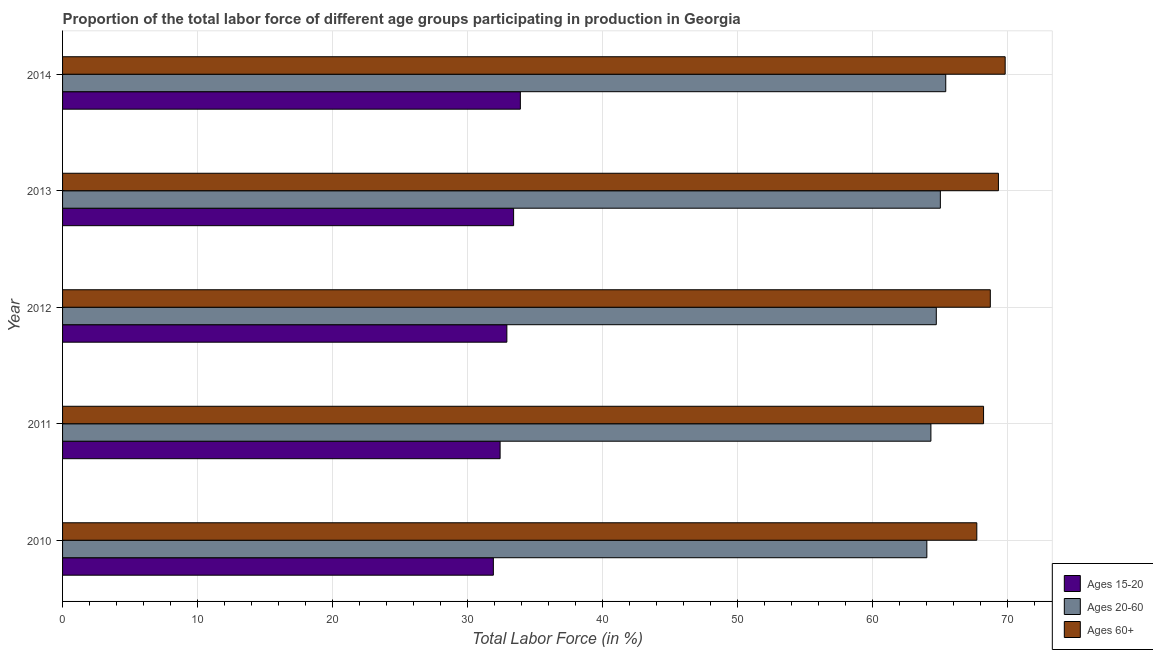In how many cases, is the number of bars for a given year not equal to the number of legend labels?
Your answer should be compact. 0. What is the percentage of labor force above age 60 in 2010?
Keep it short and to the point. 67.7. Across all years, what is the maximum percentage of labor force within the age group 20-60?
Your response must be concise. 65.4. Across all years, what is the minimum percentage of labor force above age 60?
Provide a succinct answer. 67.7. In which year was the percentage of labor force within the age group 20-60 minimum?
Provide a short and direct response. 2010. What is the total percentage of labor force above age 60 in the graph?
Your answer should be very brief. 343.7. What is the difference between the percentage of labor force within the age group 15-20 in 2013 and that in 2014?
Make the answer very short. -0.5. What is the difference between the percentage of labor force above age 60 in 2013 and the percentage of labor force within the age group 15-20 in 2011?
Ensure brevity in your answer.  36.9. What is the average percentage of labor force within the age group 20-60 per year?
Give a very brief answer. 64.68. In the year 2010, what is the difference between the percentage of labor force within the age group 20-60 and percentage of labor force above age 60?
Give a very brief answer. -3.7. What is the ratio of the percentage of labor force within the age group 15-20 in 2010 to that in 2014?
Your answer should be compact. 0.94. Is the difference between the percentage of labor force within the age group 15-20 in 2010 and 2014 greater than the difference between the percentage of labor force above age 60 in 2010 and 2014?
Give a very brief answer. Yes. What is the difference between the highest and the lowest percentage of labor force above age 60?
Your answer should be compact. 2.1. What does the 3rd bar from the top in 2012 represents?
Ensure brevity in your answer.  Ages 15-20. What does the 2nd bar from the bottom in 2014 represents?
Provide a short and direct response. Ages 20-60. Is it the case that in every year, the sum of the percentage of labor force within the age group 15-20 and percentage of labor force within the age group 20-60 is greater than the percentage of labor force above age 60?
Your answer should be very brief. Yes. How many bars are there?
Provide a succinct answer. 15. How many years are there in the graph?
Provide a succinct answer. 5. Are the values on the major ticks of X-axis written in scientific E-notation?
Ensure brevity in your answer.  No. Does the graph contain grids?
Give a very brief answer. Yes. How many legend labels are there?
Your answer should be very brief. 3. How are the legend labels stacked?
Offer a terse response. Vertical. What is the title of the graph?
Offer a terse response. Proportion of the total labor force of different age groups participating in production in Georgia. Does "Industrial Nitrous Oxide" appear as one of the legend labels in the graph?
Provide a succinct answer. No. What is the label or title of the X-axis?
Ensure brevity in your answer.  Total Labor Force (in %). What is the label or title of the Y-axis?
Keep it short and to the point. Year. What is the Total Labor Force (in %) of Ages 15-20 in 2010?
Make the answer very short. 31.9. What is the Total Labor Force (in %) in Ages 60+ in 2010?
Provide a short and direct response. 67.7. What is the Total Labor Force (in %) in Ages 15-20 in 2011?
Make the answer very short. 32.4. What is the Total Labor Force (in %) in Ages 20-60 in 2011?
Keep it short and to the point. 64.3. What is the Total Labor Force (in %) of Ages 60+ in 2011?
Make the answer very short. 68.2. What is the Total Labor Force (in %) in Ages 15-20 in 2012?
Keep it short and to the point. 32.9. What is the Total Labor Force (in %) of Ages 20-60 in 2012?
Your response must be concise. 64.7. What is the Total Labor Force (in %) of Ages 60+ in 2012?
Your answer should be compact. 68.7. What is the Total Labor Force (in %) of Ages 15-20 in 2013?
Your answer should be compact. 33.4. What is the Total Labor Force (in %) of Ages 20-60 in 2013?
Your answer should be compact. 65. What is the Total Labor Force (in %) in Ages 60+ in 2013?
Make the answer very short. 69.3. What is the Total Labor Force (in %) of Ages 15-20 in 2014?
Offer a very short reply. 33.9. What is the Total Labor Force (in %) of Ages 20-60 in 2014?
Make the answer very short. 65.4. What is the Total Labor Force (in %) of Ages 60+ in 2014?
Provide a short and direct response. 69.8. Across all years, what is the maximum Total Labor Force (in %) of Ages 15-20?
Offer a terse response. 33.9. Across all years, what is the maximum Total Labor Force (in %) of Ages 20-60?
Give a very brief answer. 65.4. Across all years, what is the maximum Total Labor Force (in %) of Ages 60+?
Ensure brevity in your answer.  69.8. Across all years, what is the minimum Total Labor Force (in %) in Ages 15-20?
Your answer should be very brief. 31.9. Across all years, what is the minimum Total Labor Force (in %) of Ages 60+?
Offer a terse response. 67.7. What is the total Total Labor Force (in %) in Ages 15-20 in the graph?
Offer a very short reply. 164.5. What is the total Total Labor Force (in %) of Ages 20-60 in the graph?
Provide a short and direct response. 323.4. What is the total Total Labor Force (in %) in Ages 60+ in the graph?
Your answer should be compact. 343.7. What is the difference between the Total Labor Force (in %) of Ages 15-20 in 2010 and that in 2011?
Your answer should be compact. -0.5. What is the difference between the Total Labor Force (in %) of Ages 60+ in 2010 and that in 2011?
Offer a very short reply. -0.5. What is the difference between the Total Labor Force (in %) of Ages 15-20 in 2010 and that in 2012?
Make the answer very short. -1. What is the difference between the Total Labor Force (in %) of Ages 60+ in 2010 and that in 2013?
Your answer should be very brief. -1.6. What is the difference between the Total Labor Force (in %) of Ages 20-60 in 2010 and that in 2014?
Your answer should be very brief. -1.4. What is the difference between the Total Labor Force (in %) in Ages 60+ in 2010 and that in 2014?
Your response must be concise. -2.1. What is the difference between the Total Labor Force (in %) of Ages 60+ in 2011 and that in 2013?
Keep it short and to the point. -1.1. What is the difference between the Total Labor Force (in %) in Ages 15-20 in 2011 and that in 2014?
Make the answer very short. -1.5. What is the difference between the Total Labor Force (in %) of Ages 20-60 in 2011 and that in 2014?
Your answer should be very brief. -1.1. What is the difference between the Total Labor Force (in %) of Ages 60+ in 2011 and that in 2014?
Give a very brief answer. -1.6. What is the difference between the Total Labor Force (in %) in Ages 15-20 in 2012 and that in 2013?
Offer a very short reply. -0.5. What is the difference between the Total Labor Force (in %) in Ages 20-60 in 2012 and that in 2013?
Your answer should be very brief. -0.3. What is the difference between the Total Labor Force (in %) of Ages 60+ in 2012 and that in 2013?
Make the answer very short. -0.6. What is the difference between the Total Labor Force (in %) of Ages 20-60 in 2012 and that in 2014?
Provide a short and direct response. -0.7. What is the difference between the Total Labor Force (in %) in Ages 20-60 in 2013 and that in 2014?
Provide a succinct answer. -0.4. What is the difference between the Total Labor Force (in %) in Ages 15-20 in 2010 and the Total Labor Force (in %) in Ages 20-60 in 2011?
Your answer should be very brief. -32.4. What is the difference between the Total Labor Force (in %) of Ages 15-20 in 2010 and the Total Labor Force (in %) of Ages 60+ in 2011?
Your answer should be compact. -36.3. What is the difference between the Total Labor Force (in %) of Ages 20-60 in 2010 and the Total Labor Force (in %) of Ages 60+ in 2011?
Your answer should be very brief. -4.2. What is the difference between the Total Labor Force (in %) of Ages 15-20 in 2010 and the Total Labor Force (in %) of Ages 20-60 in 2012?
Your answer should be compact. -32.8. What is the difference between the Total Labor Force (in %) in Ages 15-20 in 2010 and the Total Labor Force (in %) in Ages 60+ in 2012?
Offer a terse response. -36.8. What is the difference between the Total Labor Force (in %) in Ages 15-20 in 2010 and the Total Labor Force (in %) in Ages 20-60 in 2013?
Your response must be concise. -33.1. What is the difference between the Total Labor Force (in %) in Ages 15-20 in 2010 and the Total Labor Force (in %) in Ages 60+ in 2013?
Ensure brevity in your answer.  -37.4. What is the difference between the Total Labor Force (in %) in Ages 20-60 in 2010 and the Total Labor Force (in %) in Ages 60+ in 2013?
Provide a short and direct response. -5.3. What is the difference between the Total Labor Force (in %) of Ages 15-20 in 2010 and the Total Labor Force (in %) of Ages 20-60 in 2014?
Give a very brief answer. -33.5. What is the difference between the Total Labor Force (in %) in Ages 15-20 in 2010 and the Total Labor Force (in %) in Ages 60+ in 2014?
Your answer should be very brief. -37.9. What is the difference between the Total Labor Force (in %) of Ages 15-20 in 2011 and the Total Labor Force (in %) of Ages 20-60 in 2012?
Provide a succinct answer. -32.3. What is the difference between the Total Labor Force (in %) in Ages 15-20 in 2011 and the Total Labor Force (in %) in Ages 60+ in 2012?
Your response must be concise. -36.3. What is the difference between the Total Labor Force (in %) in Ages 15-20 in 2011 and the Total Labor Force (in %) in Ages 20-60 in 2013?
Your answer should be very brief. -32.6. What is the difference between the Total Labor Force (in %) in Ages 15-20 in 2011 and the Total Labor Force (in %) in Ages 60+ in 2013?
Your answer should be very brief. -36.9. What is the difference between the Total Labor Force (in %) of Ages 15-20 in 2011 and the Total Labor Force (in %) of Ages 20-60 in 2014?
Your response must be concise. -33. What is the difference between the Total Labor Force (in %) in Ages 15-20 in 2011 and the Total Labor Force (in %) in Ages 60+ in 2014?
Keep it short and to the point. -37.4. What is the difference between the Total Labor Force (in %) in Ages 15-20 in 2012 and the Total Labor Force (in %) in Ages 20-60 in 2013?
Provide a succinct answer. -32.1. What is the difference between the Total Labor Force (in %) in Ages 15-20 in 2012 and the Total Labor Force (in %) in Ages 60+ in 2013?
Keep it short and to the point. -36.4. What is the difference between the Total Labor Force (in %) of Ages 20-60 in 2012 and the Total Labor Force (in %) of Ages 60+ in 2013?
Your answer should be compact. -4.6. What is the difference between the Total Labor Force (in %) in Ages 15-20 in 2012 and the Total Labor Force (in %) in Ages 20-60 in 2014?
Make the answer very short. -32.5. What is the difference between the Total Labor Force (in %) of Ages 15-20 in 2012 and the Total Labor Force (in %) of Ages 60+ in 2014?
Make the answer very short. -36.9. What is the difference between the Total Labor Force (in %) in Ages 15-20 in 2013 and the Total Labor Force (in %) in Ages 20-60 in 2014?
Provide a short and direct response. -32. What is the difference between the Total Labor Force (in %) of Ages 15-20 in 2013 and the Total Labor Force (in %) of Ages 60+ in 2014?
Ensure brevity in your answer.  -36.4. What is the difference between the Total Labor Force (in %) in Ages 20-60 in 2013 and the Total Labor Force (in %) in Ages 60+ in 2014?
Ensure brevity in your answer.  -4.8. What is the average Total Labor Force (in %) in Ages 15-20 per year?
Your answer should be compact. 32.9. What is the average Total Labor Force (in %) in Ages 20-60 per year?
Your answer should be very brief. 64.68. What is the average Total Labor Force (in %) in Ages 60+ per year?
Your answer should be very brief. 68.74. In the year 2010, what is the difference between the Total Labor Force (in %) of Ages 15-20 and Total Labor Force (in %) of Ages 20-60?
Keep it short and to the point. -32.1. In the year 2010, what is the difference between the Total Labor Force (in %) in Ages 15-20 and Total Labor Force (in %) in Ages 60+?
Your answer should be compact. -35.8. In the year 2010, what is the difference between the Total Labor Force (in %) in Ages 20-60 and Total Labor Force (in %) in Ages 60+?
Provide a short and direct response. -3.7. In the year 2011, what is the difference between the Total Labor Force (in %) in Ages 15-20 and Total Labor Force (in %) in Ages 20-60?
Your response must be concise. -31.9. In the year 2011, what is the difference between the Total Labor Force (in %) in Ages 15-20 and Total Labor Force (in %) in Ages 60+?
Give a very brief answer. -35.8. In the year 2011, what is the difference between the Total Labor Force (in %) in Ages 20-60 and Total Labor Force (in %) in Ages 60+?
Offer a terse response. -3.9. In the year 2012, what is the difference between the Total Labor Force (in %) in Ages 15-20 and Total Labor Force (in %) in Ages 20-60?
Make the answer very short. -31.8. In the year 2012, what is the difference between the Total Labor Force (in %) of Ages 15-20 and Total Labor Force (in %) of Ages 60+?
Ensure brevity in your answer.  -35.8. In the year 2013, what is the difference between the Total Labor Force (in %) of Ages 15-20 and Total Labor Force (in %) of Ages 20-60?
Ensure brevity in your answer.  -31.6. In the year 2013, what is the difference between the Total Labor Force (in %) of Ages 15-20 and Total Labor Force (in %) of Ages 60+?
Your response must be concise. -35.9. In the year 2013, what is the difference between the Total Labor Force (in %) in Ages 20-60 and Total Labor Force (in %) in Ages 60+?
Ensure brevity in your answer.  -4.3. In the year 2014, what is the difference between the Total Labor Force (in %) in Ages 15-20 and Total Labor Force (in %) in Ages 20-60?
Give a very brief answer. -31.5. In the year 2014, what is the difference between the Total Labor Force (in %) of Ages 15-20 and Total Labor Force (in %) of Ages 60+?
Your answer should be very brief. -35.9. In the year 2014, what is the difference between the Total Labor Force (in %) in Ages 20-60 and Total Labor Force (in %) in Ages 60+?
Your answer should be very brief. -4.4. What is the ratio of the Total Labor Force (in %) in Ages 15-20 in 2010 to that in 2011?
Give a very brief answer. 0.98. What is the ratio of the Total Labor Force (in %) in Ages 15-20 in 2010 to that in 2012?
Make the answer very short. 0.97. What is the ratio of the Total Labor Force (in %) in Ages 60+ in 2010 to that in 2012?
Provide a succinct answer. 0.99. What is the ratio of the Total Labor Force (in %) in Ages 15-20 in 2010 to that in 2013?
Provide a short and direct response. 0.96. What is the ratio of the Total Labor Force (in %) in Ages 20-60 in 2010 to that in 2013?
Your response must be concise. 0.98. What is the ratio of the Total Labor Force (in %) in Ages 60+ in 2010 to that in 2013?
Make the answer very short. 0.98. What is the ratio of the Total Labor Force (in %) of Ages 15-20 in 2010 to that in 2014?
Provide a succinct answer. 0.94. What is the ratio of the Total Labor Force (in %) in Ages 20-60 in 2010 to that in 2014?
Provide a succinct answer. 0.98. What is the ratio of the Total Labor Force (in %) of Ages 60+ in 2010 to that in 2014?
Ensure brevity in your answer.  0.97. What is the ratio of the Total Labor Force (in %) of Ages 15-20 in 2011 to that in 2012?
Offer a terse response. 0.98. What is the ratio of the Total Labor Force (in %) of Ages 15-20 in 2011 to that in 2013?
Give a very brief answer. 0.97. What is the ratio of the Total Labor Force (in %) of Ages 60+ in 2011 to that in 2013?
Keep it short and to the point. 0.98. What is the ratio of the Total Labor Force (in %) in Ages 15-20 in 2011 to that in 2014?
Your answer should be compact. 0.96. What is the ratio of the Total Labor Force (in %) in Ages 20-60 in 2011 to that in 2014?
Give a very brief answer. 0.98. What is the ratio of the Total Labor Force (in %) of Ages 60+ in 2011 to that in 2014?
Make the answer very short. 0.98. What is the ratio of the Total Labor Force (in %) in Ages 15-20 in 2012 to that in 2013?
Your response must be concise. 0.98. What is the ratio of the Total Labor Force (in %) in Ages 60+ in 2012 to that in 2013?
Make the answer very short. 0.99. What is the ratio of the Total Labor Force (in %) in Ages 15-20 in 2012 to that in 2014?
Provide a succinct answer. 0.97. What is the ratio of the Total Labor Force (in %) in Ages 20-60 in 2012 to that in 2014?
Keep it short and to the point. 0.99. What is the ratio of the Total Labor Force (in %) of Ages 60+ in 2012 to that in 2014?
Provide a short and direct response. 0.98. What is the difference between the highest and the second highest Total Labor Force (in %) of Ages 60+?
Your answer should be very brief. 0.5. What is the difference between the highest and the lowest Total Labor Force (in %) in Ages 20-60?
Provide a short and direct response. 1.4. What is the difference between the highest and the lowest Total Labor Force (in %) of Ages 60+?
Give a very brief answer. 2.1. 